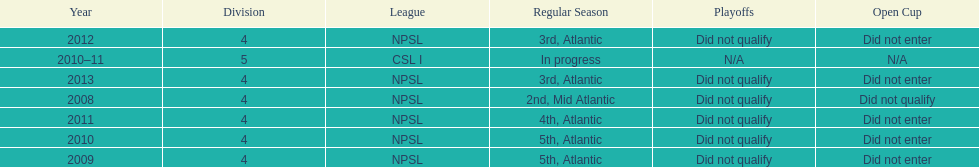Using the data, what should be the next year they will play? 2014. 